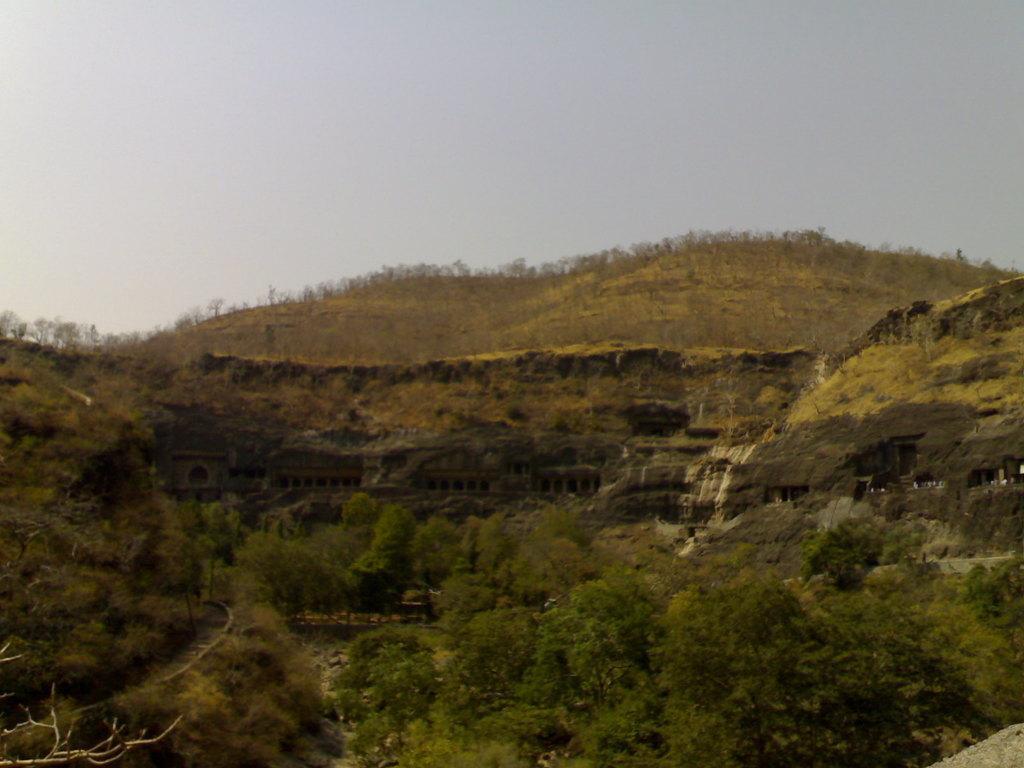Please provide a concise description of this image. In this image we can see a building, a group of trees, the hills and the sky which looks cloudy. 